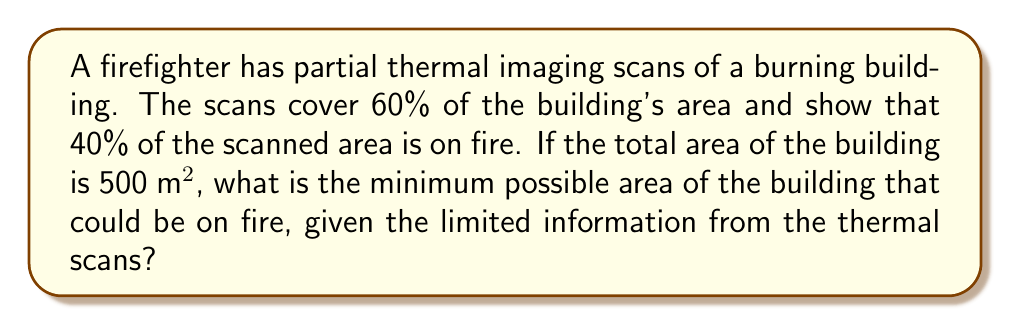Can you solve this math problem? Let's approach this step-by-step:

1) First, let's define our variables:
   $A$ = Total area of the building = 500 m²
   $S$ = Scanned area
   $F$ = Area on fire in the scanned portion

2) We know that the scans cover 60% of the building's area:
   $S = 0.60 \times A = 0.60 \times 500 = 300$ m²

3) We're told that 40% of the scanned area is on fire:
   $F = 0.40 \times S = 0.40 \times 300 = 120$ m²

4) Now, we need to consider the worst-case scenario for the unscanned area. The minimum possible area on fire would occur if there's no fire in the unscanned portion.

5) The unscanned area is:
   $U = A - S = 500 - 300 = 200$ m²

6) Therefore, the minimum possible area on fire is just the area we know is on fire from the scanned portion:
   $F_{min} = F = 120$ m²

This approach considers the limitations of partial information, which is crucial in firefighting scenarios where complete data might not be available.
Answer: 120 m² 